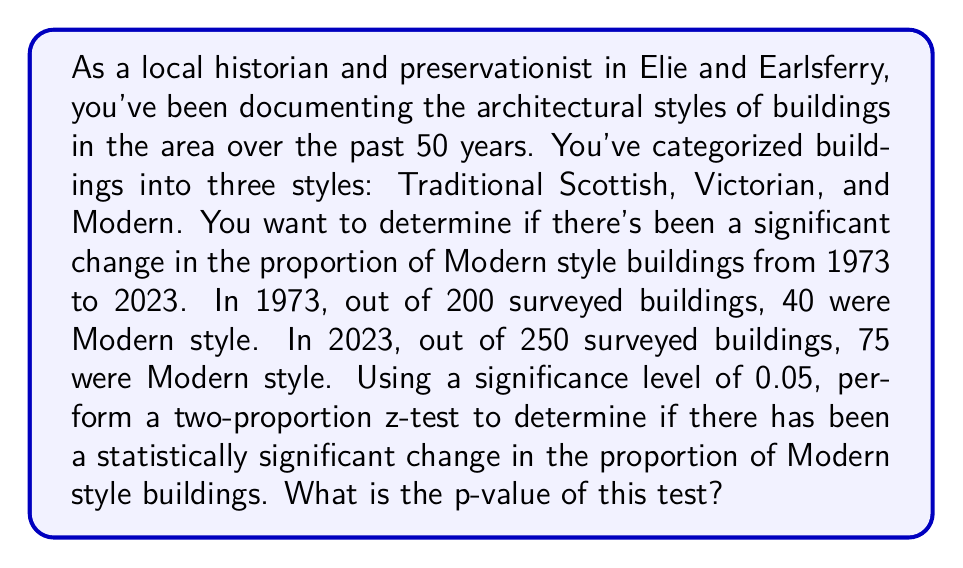Provide a solution to this math problem. To solve this problem, we'll use a two-proportion z-test. Here are the steps:

1. Define the null and alternative hypotheses:
   $H_0: p_1 = p_2$ (no change in proportion)
   $H_a: p_1 \neq p_2$ (change in proportion)

2. Calculate the sample proportions:
   1973: $\hat{p}_1 = \frac{40}{200} = 0.2$
   2023: $\hat{p}_2 = \frac{75}{250} = 0.3$

3. Calculate the pooled proportion:
   $$\hat{p} = \frac{X_1 + X_2}{n_1 + n_2} = \frac{40 + 75}{200 + 250} = \frac{115}{450} = 0.2556$$

4. Calculate the standard error:
   $$SE = \sqrt{\hat{p}(1-\hat{p})(\frac{1}{n_1} + \frac{1}{n_2})}$$
   $$SE = \sqrt{0.2556(1-0.2556)(\frac{1}{200} + \frac{1}{250})} = 0.0417$$

5. Calculate the z-statistic:
   $$z = \frac{\hat{p}_2 - \hat{p}_1}{SE} = \frac{0.3 - 0.2}{0.0417} = 2.3981$$

6. Find the p-value:
   For a two-tailed test, p-value = $2 * P(Z > |z|)$
   Using a standard normal distribution table or calculator:
   p-value = $2 * P(Z > 2.3981) = 2 * 0.0082 = 0.0164$
Answer: The p-value of the two-proportion z-test is 0.0164. 